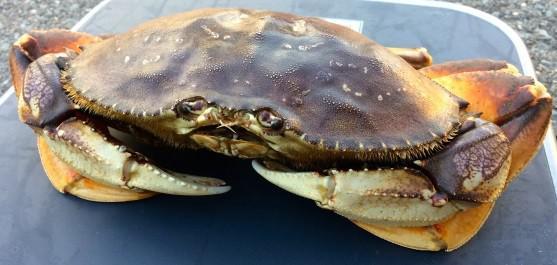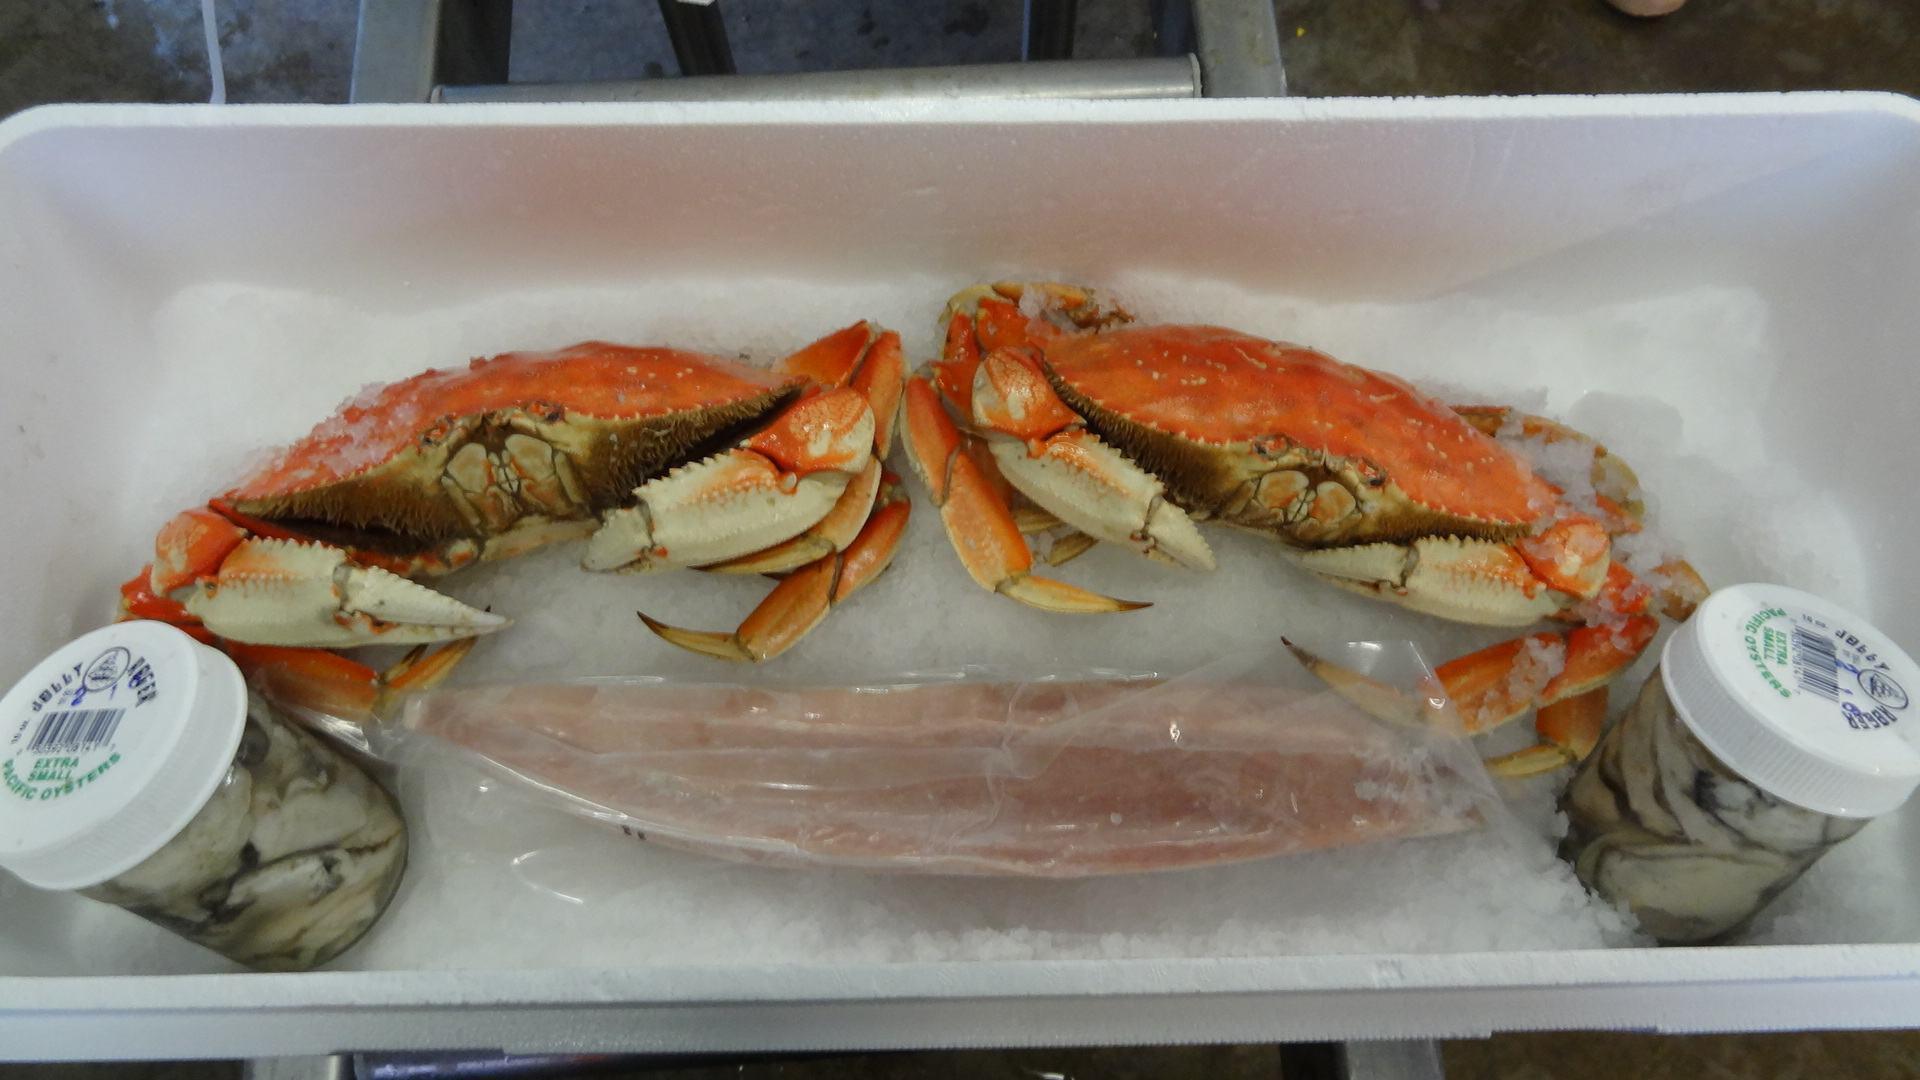The first image is the image on the left, the second image is the image on the right. Considering the images on both sides, is "A hand is holding up a crab with its face and front claws turned toward the camera in the right image." valid? Answer yes or no. No. The first image is the image on the left, the second image is the image on the right. For the images shown, is this caption "There are two small white top bottles on either side of two red crabs." true? Answer yes or no. Yes. 